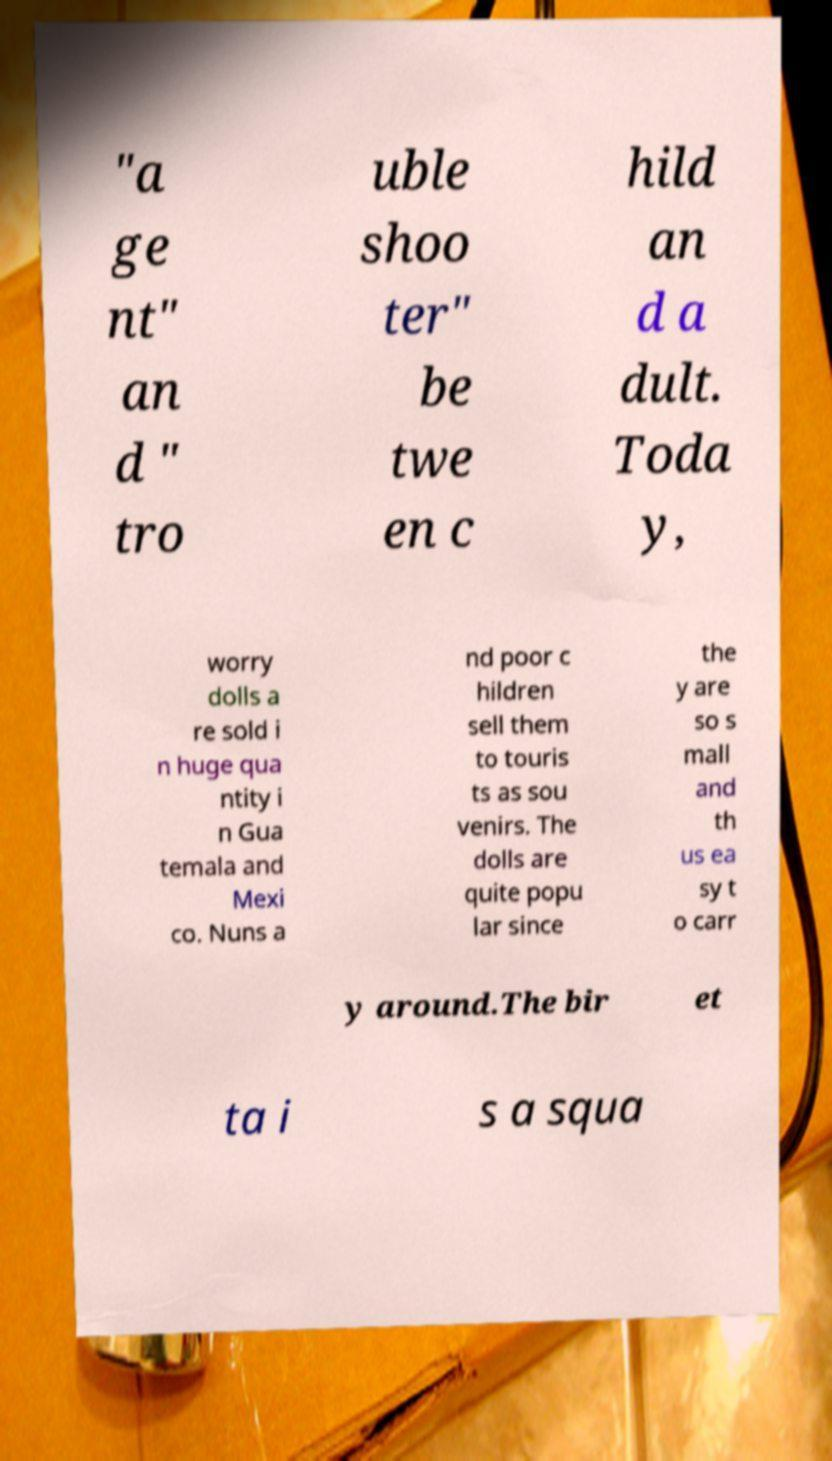Please identify and transcribe the text found in this image. "a ge nt" an d " tro uble shoo ter" be twe en c hild an d a dult. Toda y, worry dolls a re sold i n huge qua ntity i n Gua temala and Mexi co. Nuns a nd poor c hildren sell them to touris ts as sou venirs. The dolls are quite popu lar since the y are so s mall and th us ea sy t o carr y around.The bir et ta i s a squa 